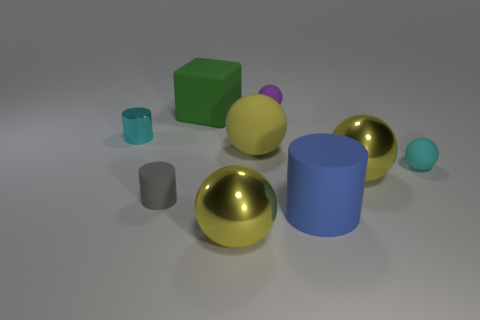There is a small shiny cylinder; does it have the same color as the small rubber sphere that is in front of the large green cube? Yes, the small shiny cylinder and the small rubber sphere share the same hue of silver-gray, exhibiting a visual harmony between the objects despite their differences in shape and texture. 